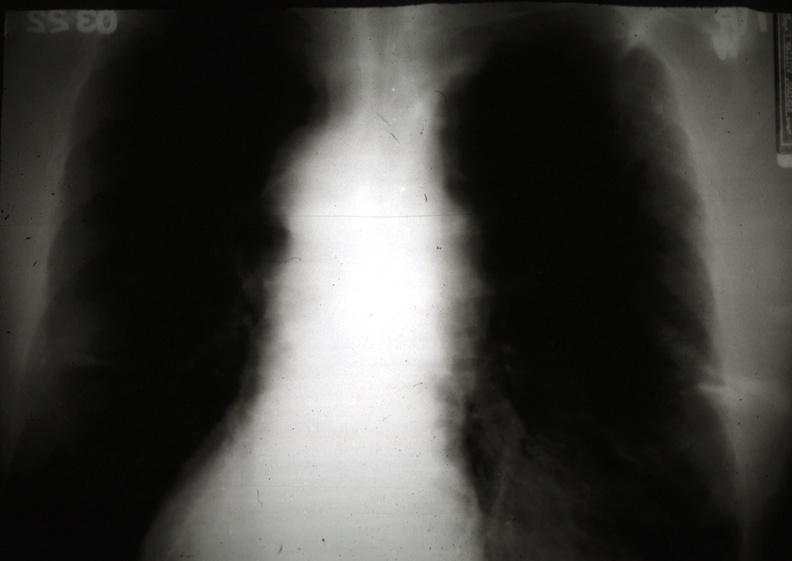what is present?
Answer the question using a single word or phrase. Thymus 